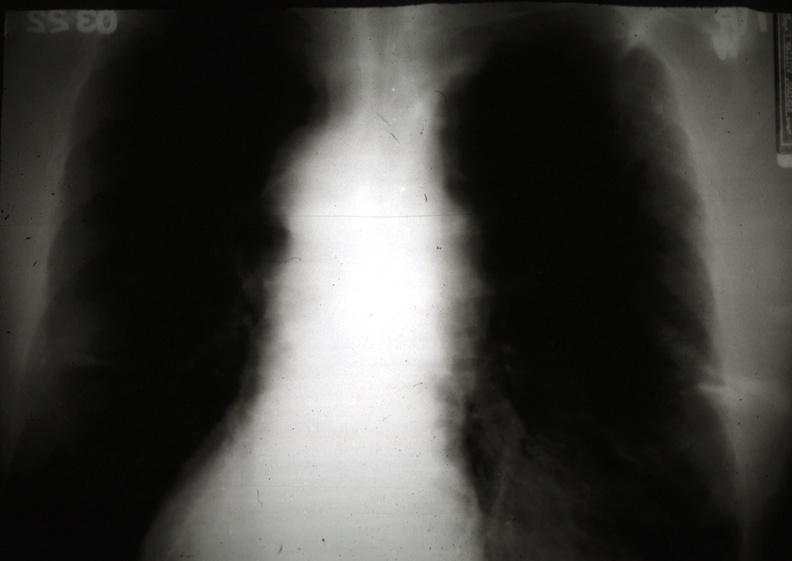what is present?
Answer the question using a single word or phrase. Thymus 